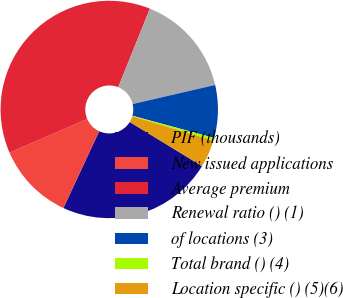Convert chart. <chart><loc_0><loc_0><loc_500><loc_500><pie_chart><fcel>PIF (thousands)<fcel>New issued applications<fcel>Average premium<fcel>Renewal ratio () (1)<fcel>of locations (3)<fcel>Total brand () (4)<fcel>Location specific () (5)(6)<nl><fcel>23.21%<fcel>11.56%<fcel>37.61%<fcel>15.28%<fcel>7.84%<fcel>0.39%<fcel>4.11%<nl></chart> 